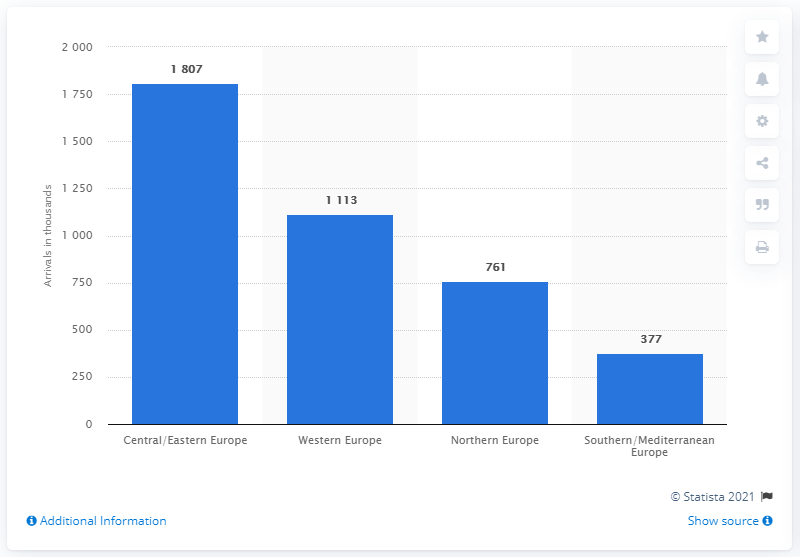Identify some key points in this picture. According to statistics, in 2019, the region that was most visited by Indian tourists was Central/Eastern Europe. 